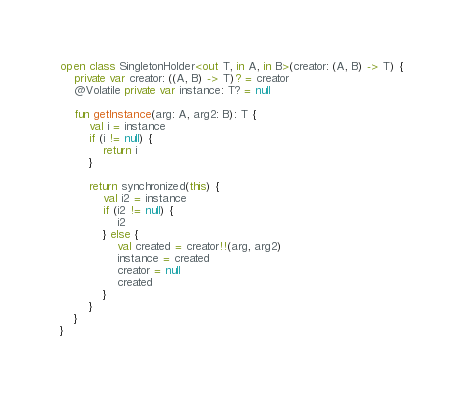Convert code to text. <code><loc_0><loc_0><loc_500><loc_500><_Kotlin_>open class SingletonHolder<out T, in A, in B>(creator: (A, B) -> T) {
    private var creator: ((A, B) -> T)? = creator
    @Volatile private var instance: T? = null

    fun getInstance(arg: A, arg2: B): T {
        val i = instance
        if (i != null) {
            return i
        }

        return synchronized(this) {
            val i2 = instance
            if (i2 != null) {
                i2
            } else {
                val created = creator!!(arg, arg2)
                instance = created
                creator = null
                created
            }
        }
    }
}</code> 